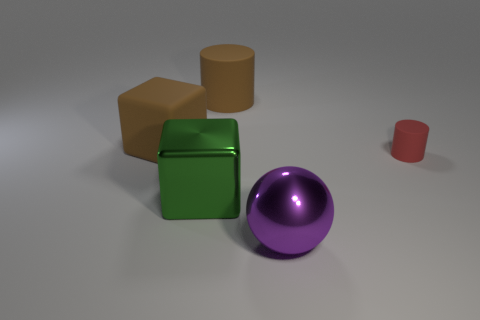What is the shape of the purple object that is the same size as the green cube? The purple object, which is the same size as the green cube, has the shape of a sphere, characterized by its perfectly round geometry. 